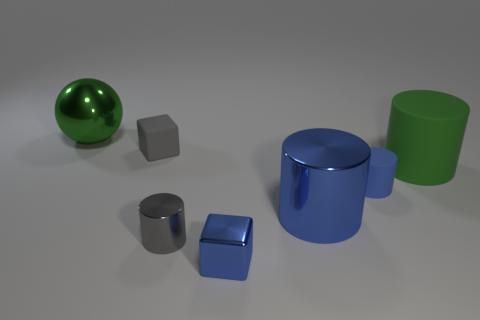Subtract all gray cylinders. How many cylinders are left? 3 Subtract all gray cylinders. How many cylinders are left? 3 Add 2 big metallic balls. How many objects exist? 9 Subtract all brown cylinders. Subtract all green blocks. How many cylinders are left? 4 Subtract all cylinders. How many objects are left? 3 Subtract all big blue shiny objects. Subtract all shiny cylinders. How many objects are left? 4 Add 4 large green objects. How many large green objects are left? 6 Add 5 gray cubes. How many gray cubes exist? 6 Subtract 0 yellow balls. How many objects are left? 7 